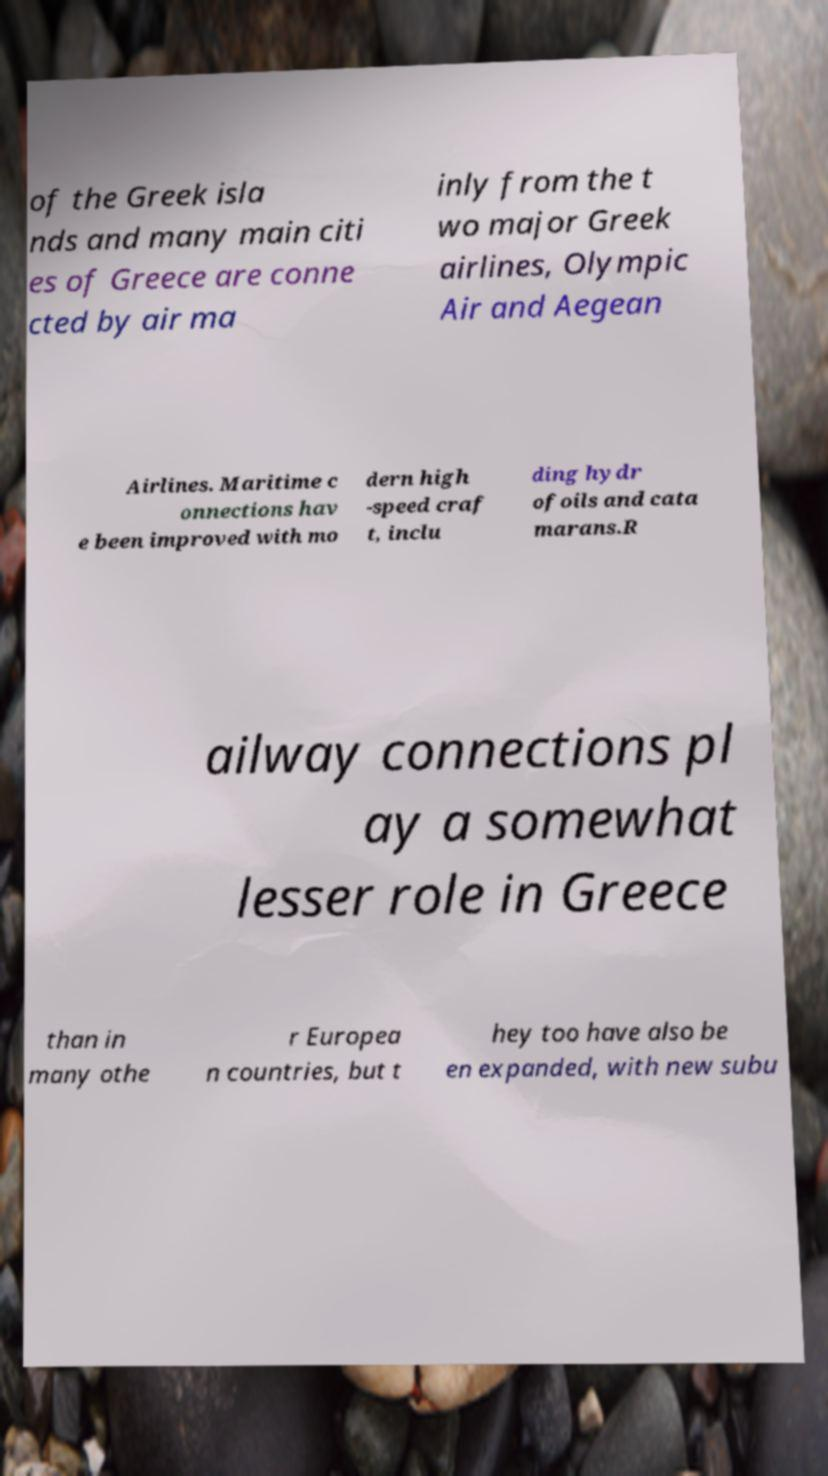There's text embedded in this image that I need extracted. Can you transcribe it verbatim? of the Greek isla nds and many main citi es of Greece are conne cted by air ma inly from the t wo major Greek airlines, Olympic Air and Aegean Airlines. Maritime c onnections hav e been improved with mo dern high -speed craf t, inclu ding hydr ofoils and cata marans.R ailway connections pl ay a somewhat lesser role in Greece than in many othe r Europea n countries, but t hey too have also be en expanded, with new subu 